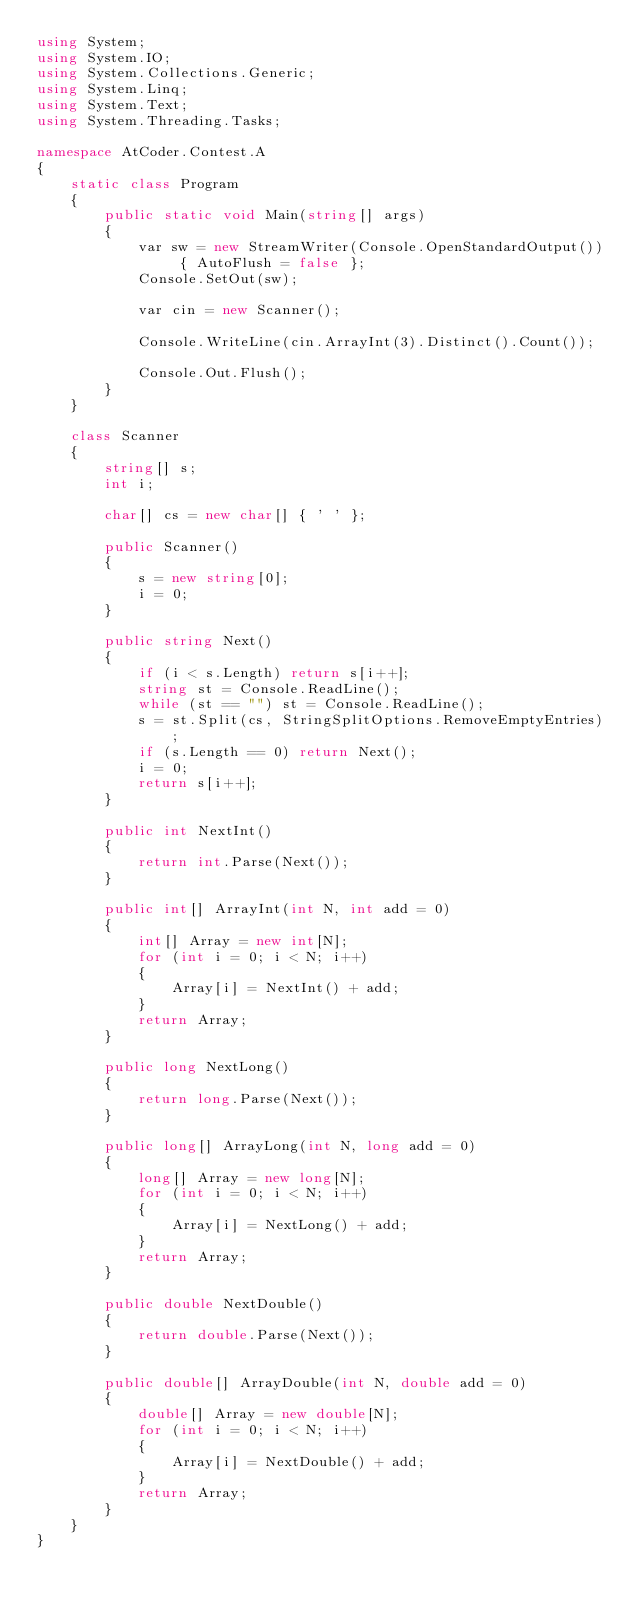Convert code to text. <code><loc_0><loc_0><loc_500><loc_500><_C#_>using System;
using System.IO;
using System.Collections.Generic;
using System.Linq;
using System.Text;
using System.Threading.Tasks;

namespace AtCoder.Contest.A
{
	static class Program
	{
		public static void Main(string[] args)
		{
			var sw = new StreamWriter(Console.OpenStandardOutput()) { AutoFlush = false };
			Console.SetOut(sw);

			var cin = new Scanner();

            Console.WriteLine(cin.ArrayInt(3).Distinct().Count());

			Console.Out.Flush();
		}
	}

	class Scanner
	{
		string[] s;
		int i;

		char[] cs = new char[] { ' ' };

		public Scanner()
		{
			s = new string[0];
			i = 0;
		}

		public string Next()
		{
			if (i < s.Length) return s[i++];
			string st = Console.ReadLine();
			while (st == "") st = Console.ReadLine();
			s = st.Split(cs, StringSplitOptions.RemoveEmptyEntries);
			if (s.Length == 0) return Next();
			i = 0;
			return s[i++];
		}

		public int NextInt()
		{
			return int.Parse(Next());
		}

		public int[] ArrayInt(int N, int add = 0)
		{
			int[] Array = new int[N];
			for (int i = 0; i < N; i++)
			{
				Array[i] = NextInt() + add;
			}
			return Array;
		}

		public long NextLong()
		{
			return long.Parse(Next());
		}

		public long[] ArrayLong(int N, long add = 0)
		{
			long[] Array = new long[N];
			for (int i = 0; i < N; i++)
			{
				Array[i] = NextLong() + add;
			}
			return Array;
		}

		public double NextDouble()
		{
			return double.Parse(Next());
		}

		public double[] ArrayDouble(int N, double add = 0)
		{
			double[] Array = new double[N];
			for (int i = 0; i < N; i++)
			{
				Array[i] = NextDouble() + add;
			}
			return Array;
		}
	}
}</code> 